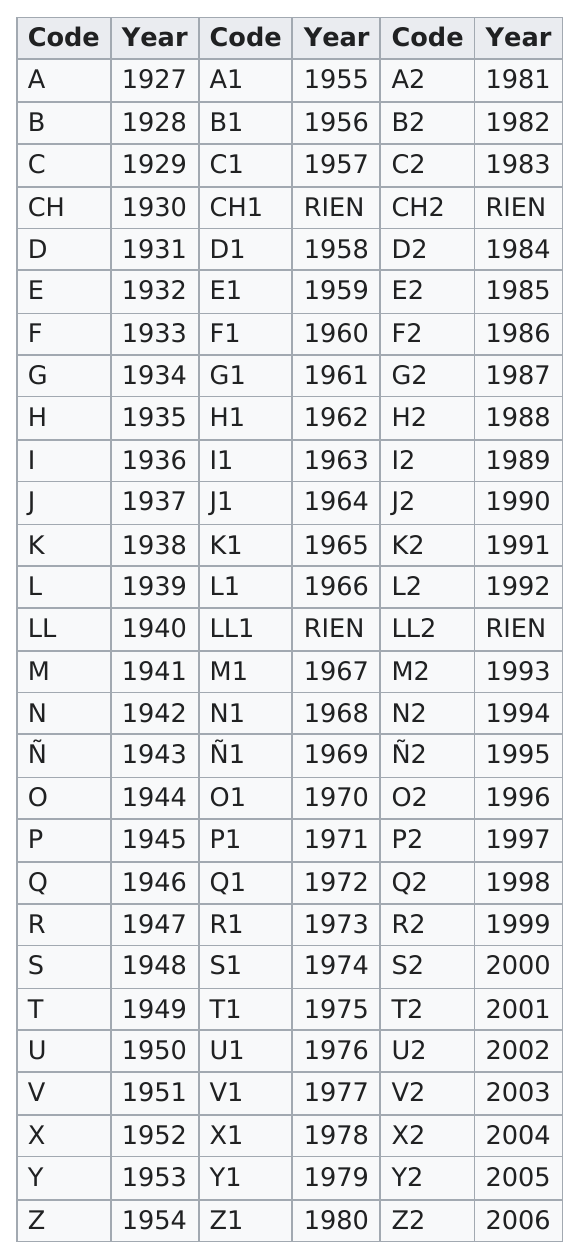Point out several critical features in this image. The codes listed below are not associated with a specific year: CH1, CH2, LL1, LL2, and any other codes that may not have been assigned a specific year. In the year 1955 and later, the Social Security Administration started using a four-digit code that included the letter "A" as the first digit. From 1953 to 1958, 6 different codes were used. There are a total of 28 possible combinations of digits that contain the digit "2" in their numeric representation. The only year to use the code "ch" was 1930. 